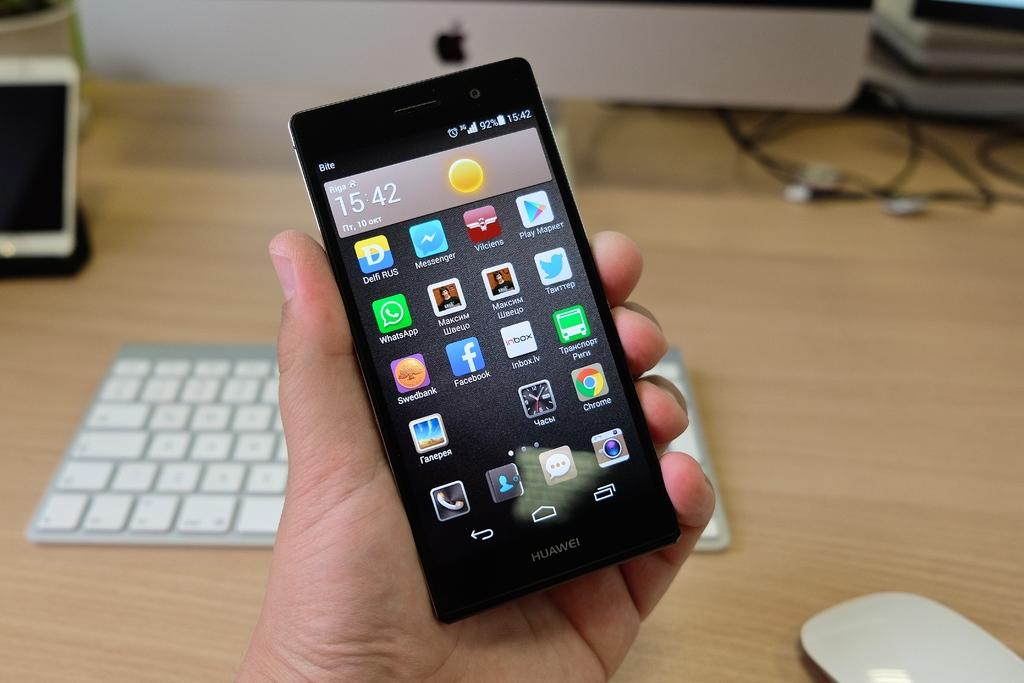<image>
Share a concise interpretation of the image provided. A person is holding a phone that says Huawei and shows the time 15:42. 